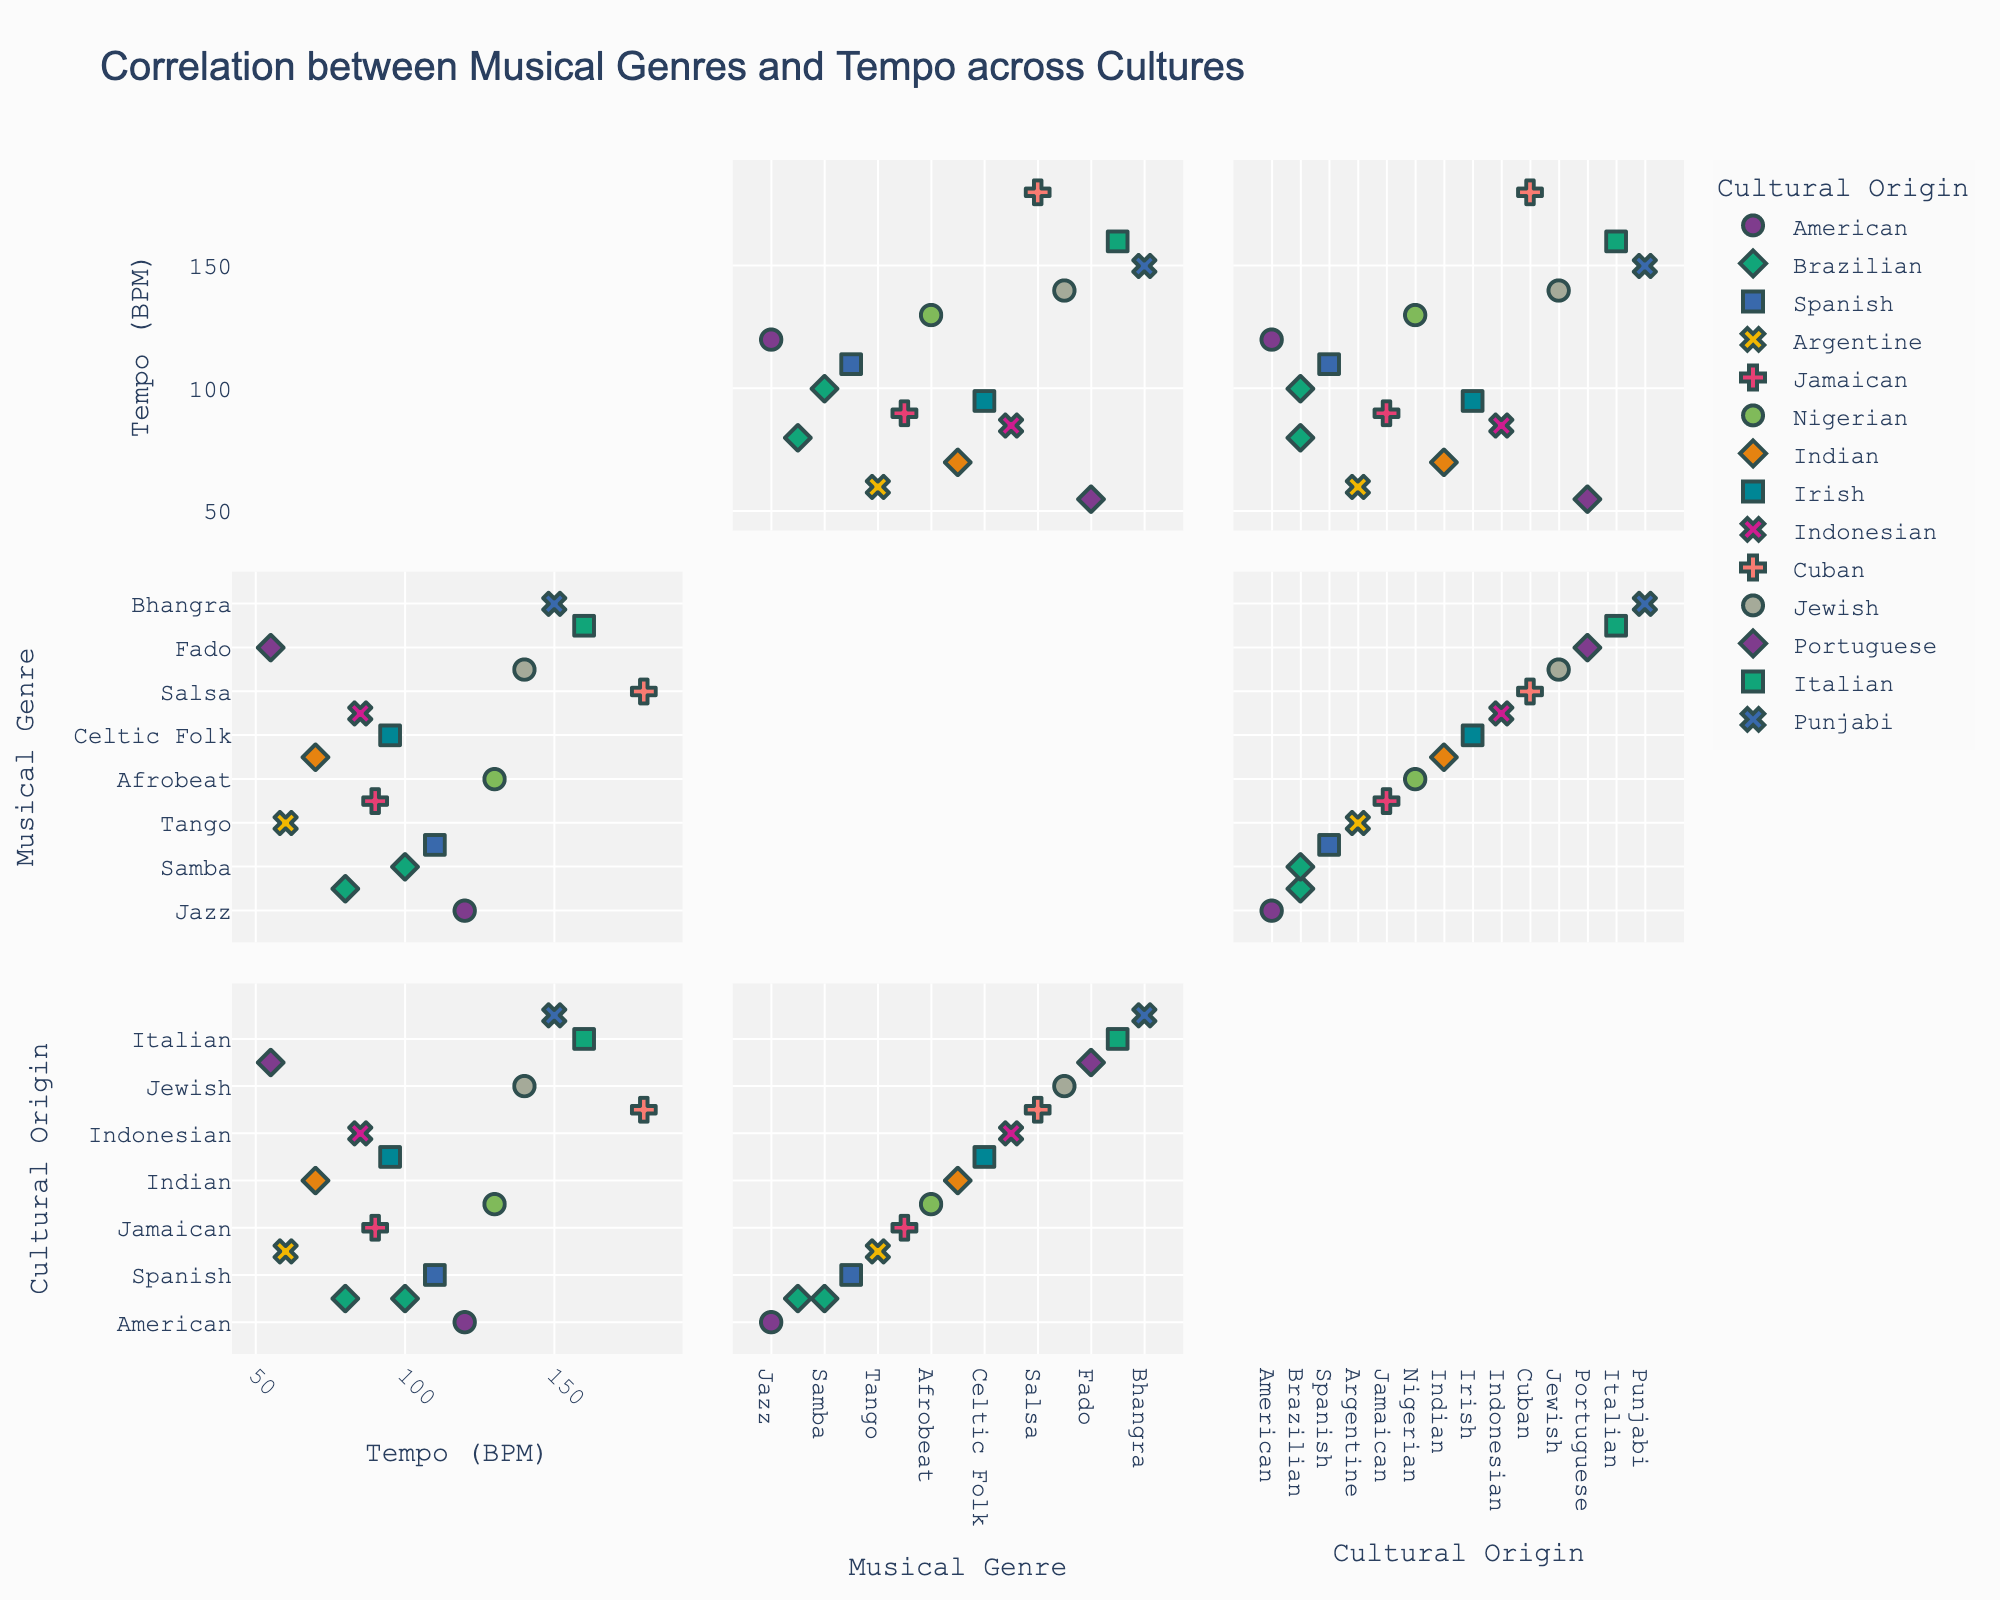How many different cultural origins are represented in the plot? By looking at the color legend in the scatterplot matrix, count the number of unique cultural origins.
Answer: 10 Which musical genre has the highest tempo, and what is its tempo? Locate the point with the highest y-value (Tempo) in the scatterplot matrix, and identify the corresponding genre and tempo.
Answer: Salsa, 180 BPM Is there any genre from the Irish culture in the plot? Examine the cultural origin labels in the scatterplot matrix for any instance labeled as "Irish".
Answer: Yes, Celtic Folk What's the average tempo of genres from the Brazilian culture? Identify all points labeled with the Brazilian culture, note their tempo values (80 BPM for Bossa Nova and 100 BPM for Samba). Calculate the average: (80 + 100) / 2 = 90 BPM
Answer: 90 BPM Which genre has a tempo greater than 150 BPM, and from which cultural origin does it come? Identify the points where the tempo exceeds 150 BPM and find the corresponding genre and cultural origin.
Answer: Tarantella, Italian Compare the tempo of Indian Classical and Afrobeat. Which genre has a higher tempo? Locate the points corresponding to Indian Classical and Afrobeat and compare their y-values (Tempo).
Answer: Afrobeat What is the tempo range (difference between the highest and lowest tempo) in the dataset? Identify the highest and lowest tempo values (180 BPM for Salsa and 55 BPM for Fado) and calculate the difference: 180 - 55 = 125 BPM.
Answer: 125 BPM Which cultural origin has the widest variety of tem with respect to their genres? Examine the scatter points grouped by cultural origin to determine which has the largest range in tempo values.
Answer: Italian (Tarantella 160 BPM) Are there any musical genres from the same cultural origin with identical tempos? Verify if there are multiple points with the same tempo value and cultural origin label.
Answer: No 